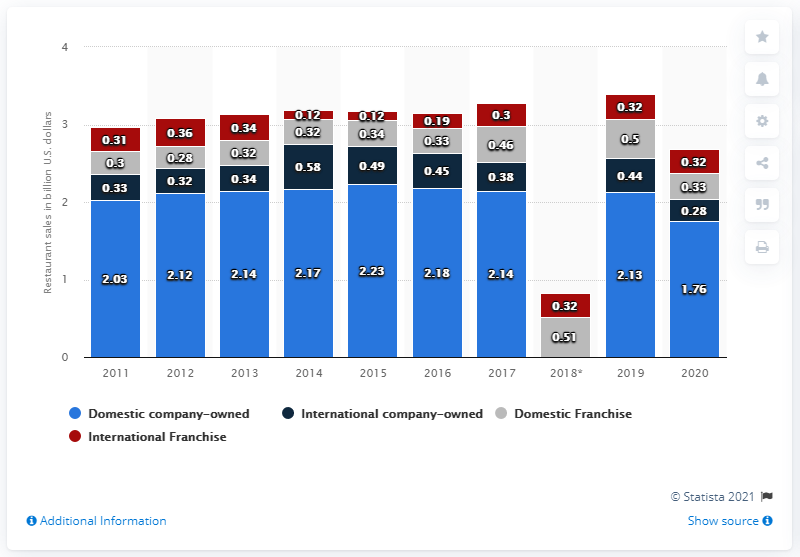Identify some key points in this picture. In 2020, the total sales of Outback Steakhouse restaurants in the United States were 1.76 billion dollars. In 2020, domestic franchise restaurants generated approximately $330 million in sales. 